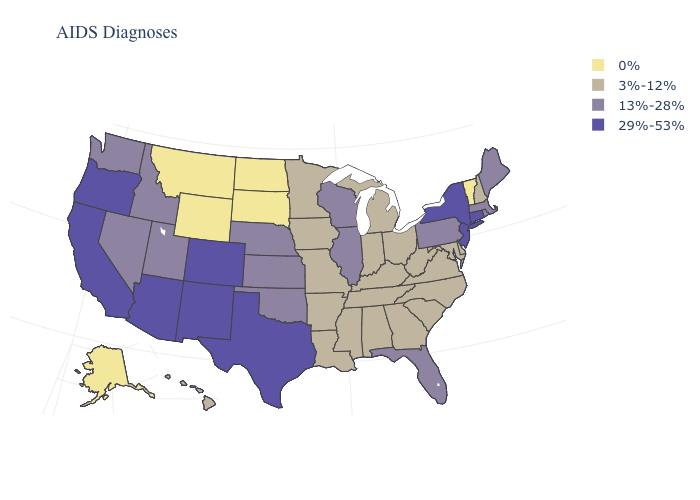Name the states that have a value in the range 3%-12%?
Quick response, please. Alabama, Arkansas, Delaware, Georgia, Hawaii, Indiana, Iowa, Kentucky, Louisiana, Maryland, Michigan, Minnesota, Mississippi, Missouri, New Hampshire, North Carolina, Ohio, South Carolina, Tennessee, Virginia, West Virginia. Name the states that have a value in the range 0%?
Answer briefly. Alaska, Montana, North Dakota, South Dakota, Vermont, Wyoming. What is the highest value in states that border Ohio?
Answer briefly. 13%-28%. Which states have the lowest value in the USA?
Keep it brief. Alaska, Montana, North Dakota, South Dakota, Vermont, Wyoming. Which states have the lowest value in the USA?
Short answer required. Alaska, Montana, North Dakota, South Dakota, Vermont, Wyoming. Name the states that have a value in the range 29%-53%?
Write a very short answer. Arizona, California, Colorado, Connecticut, New Jersey, New Mexico, New York, Oregon, Texas. What is the highest value in the USA?
Quick response, please. 29%-53%. What is the lowest value in states that border Illinois?
Quick response, please. 3%-12%. What is the value of New York?
Short answer required. 29%-53%. Among the states that border West Virginia , does Virginia have the lowest value?
Give a very brief answer. Yes. What is the highest value in states that border Arizona?
Be succinct. 29%-53%. Name the states that have a value in the range 13%-28%?
Keep it brief. Florida, Idaho, Illinois, Kansas, Maine, Massachusetts, Nebraska, Nevada, Oklahoma, Pennsylvania, Rhode Island, Utah, Washington, Wisconsin. What is the value of Nevada?
Concise answer only. 13%-28%. What is the value of Montana?
Give a very brief answer. 0%. Does the first symbol in the legend represent the smallest category?
Short answer required. Yes. 